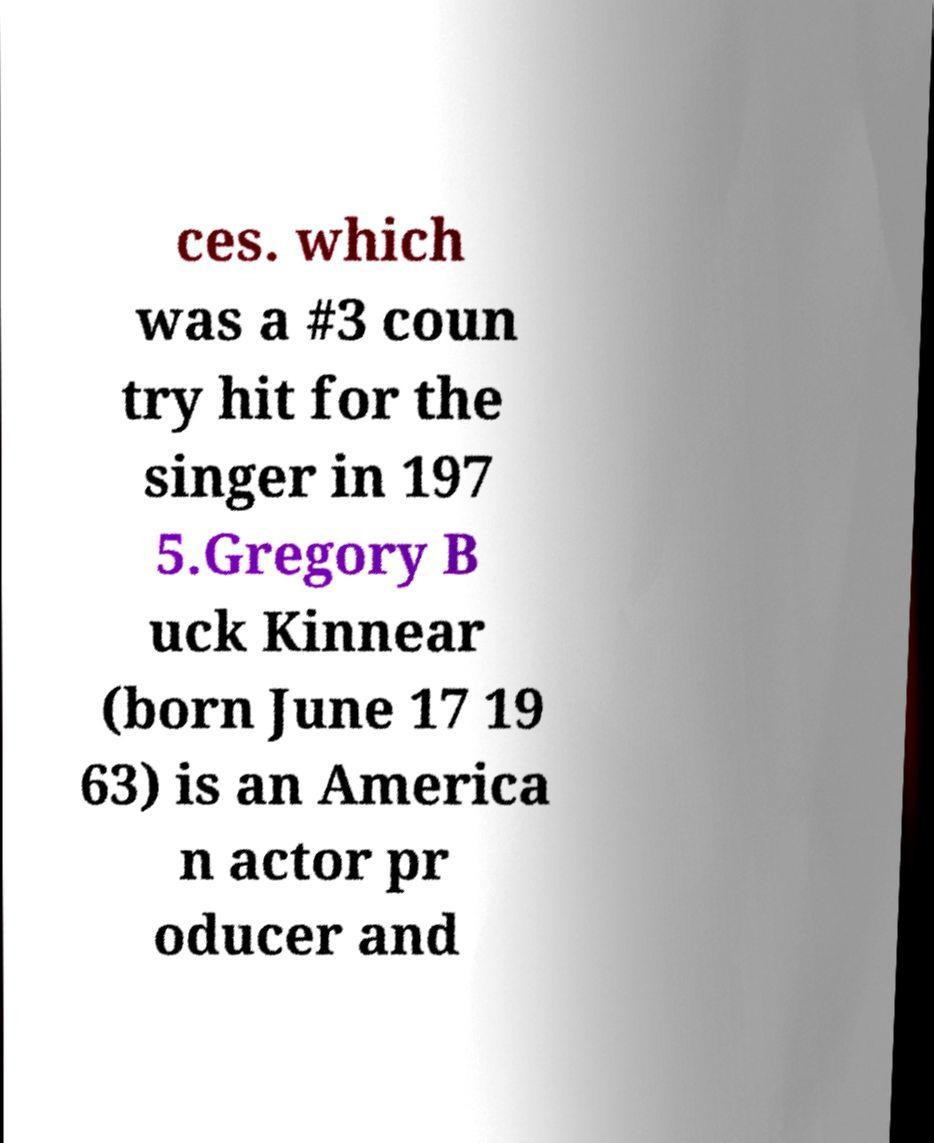There's text embedded in this image that I need extracted. Can you transcribe it verbatim? ces. which was a #3 coun try hit for the singer in 197 5.Gregory B uck Kinnear (born June 17 19 63) is an America n actor pr oducer and 